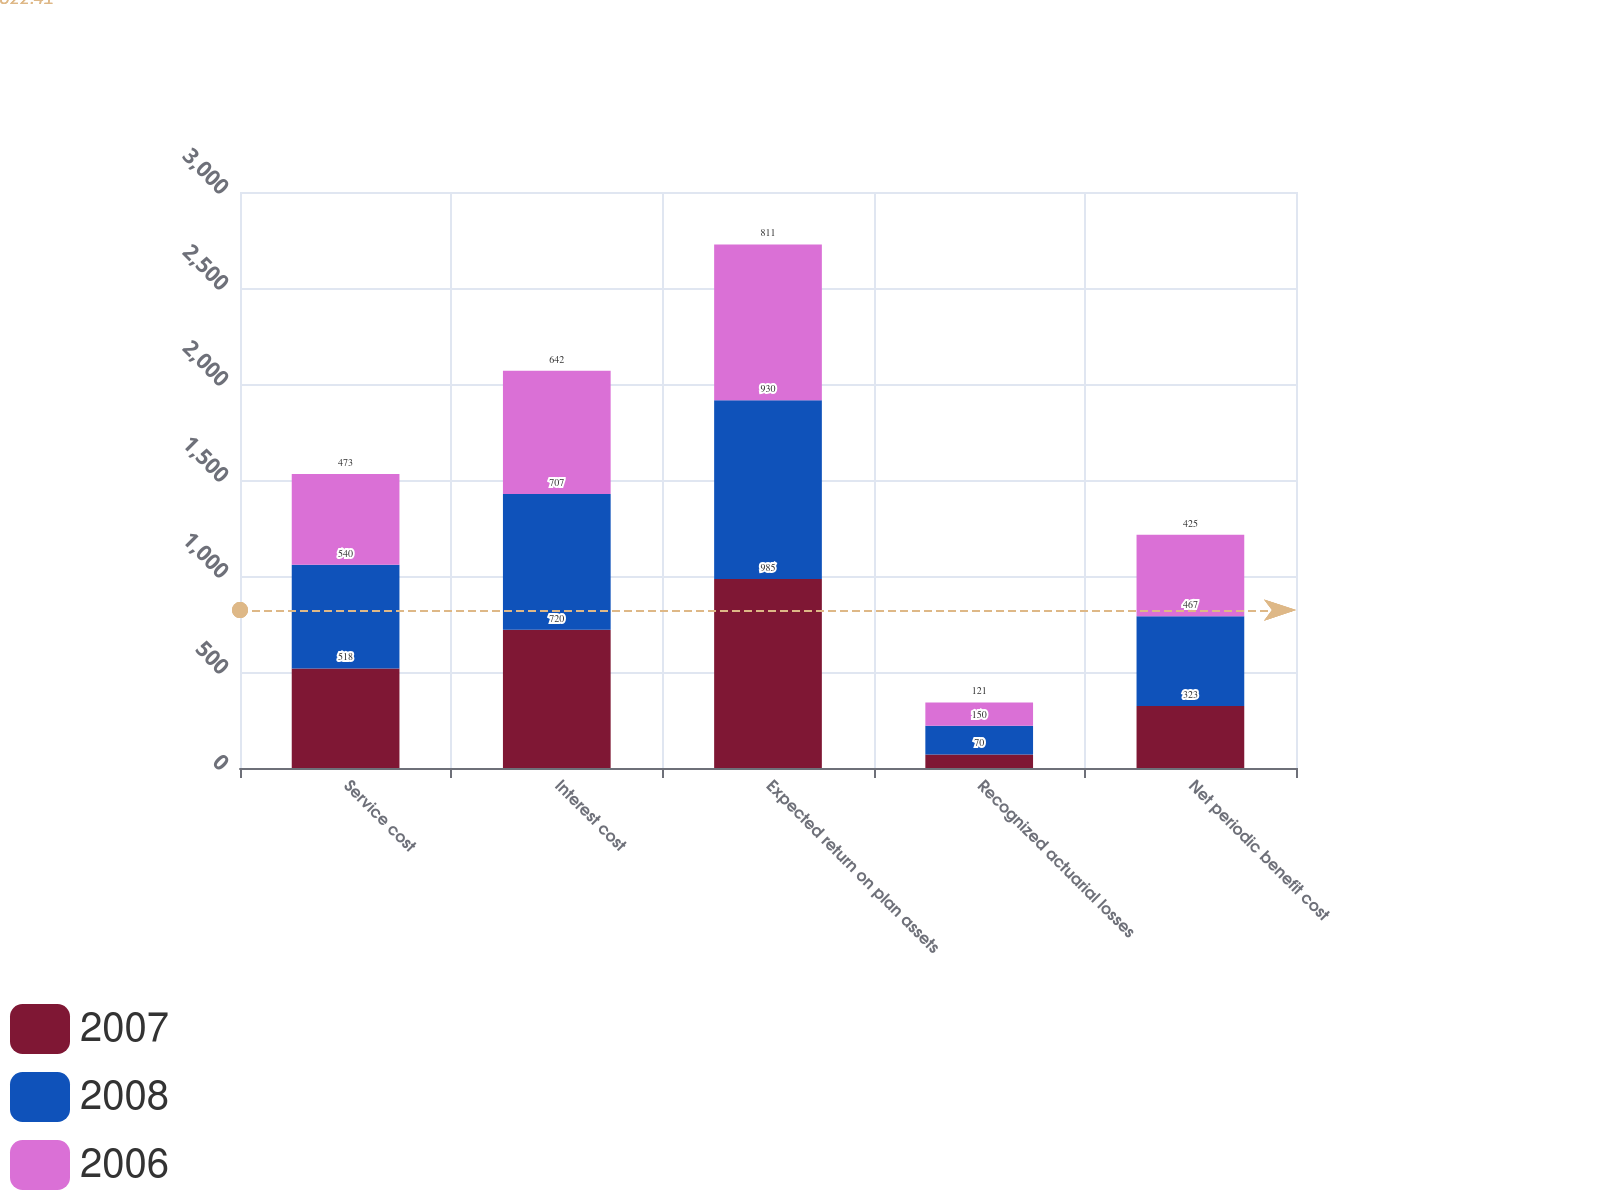<chart> <loc_0><loc_0><loc_500><loc_500><stacked_bar_chart><ecel><fcel>Service cost<fcel>Interest cost<fcel>Expected return on plan assets<fcel>Recognized actuarial losses<fcel>Net periodic benefit cost<nl><fcel>2007<fcel>518<fcel>720<fcel>985<fcel>70<fcel>323<nl><fcel>2008<fcel>540<fcel>707<fcel>930<fcel>150<fcel>467<nl><fcel>2006<fcel>473<fcel>642<fcel>811<fcel>121<fcel>425<nl></chart> 